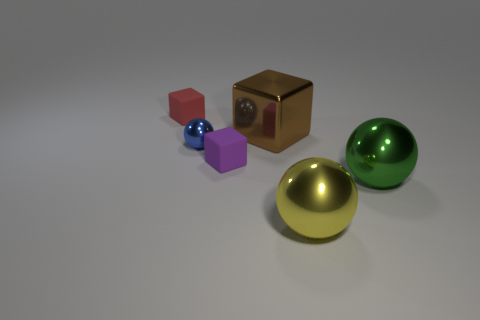What number of shiny things are either tiny things or tiny blue objects?
Make the answer very short. 1. What is the color of the matte object behind the small matte thing that is right of the small matte cube behind the big block?
Provide a short and direct response. Red. There is another large metallic object that is the same shape as the yellow metallic object; what color is it?
Give a very brief answer. Green. Is there any other thing that has the same color as the tiny shiny ball?
Give a very brief answer. No. What number of other things are there of the same material as the tiny purple block
Your answer should be compact. 1. The shiny cube is what size?
Provide a short and direct response. Large. Is there a brown thing that has the same shape as the small red rubber object?
Your response must be concise. Yes. What number of objects are small matte objects or large objects that are to the right of the big yellow shiny sphere?
Your answer should be very brief. 3. The large shiny sphere in front of the green metal thing is what color?
Make the answer very short. Yellow. There is a rubber thing that is right of the red object; does it have the same size as the rubber block that is on the left side of the tiny metallic sphere?
Your answer should be compact. Yes. 